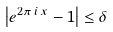<formula> <loc_0><loc_0><loc_500><loc_500>\left | e ^ { 2 \pi \, i \, x } - 1 \right | \leq \delta</formula> 